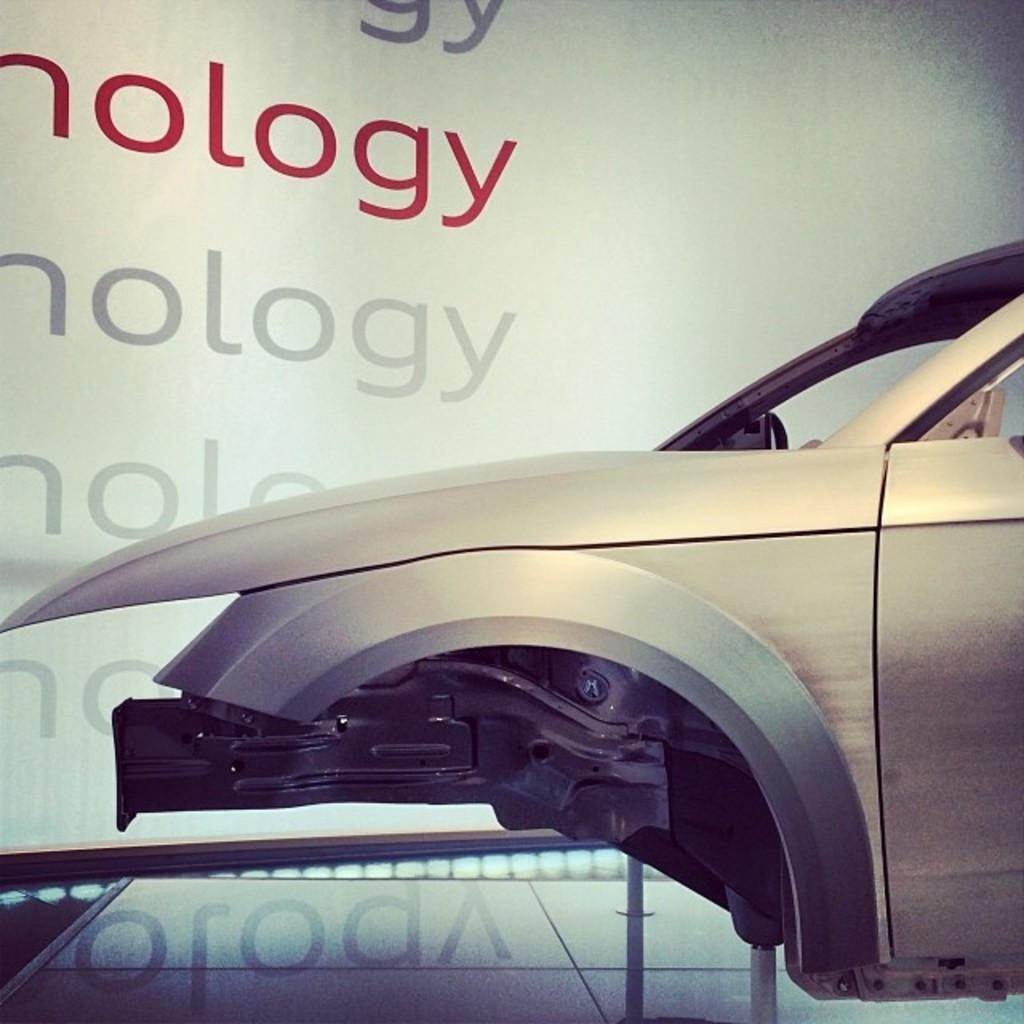What is the main subject of the picture? The main subject of the picture is a vehicle. What can be seen on the back of the vehicle? There is text on a board at the back of the vehicle. What object is located at the bottom of the image? There is a glass at the bottom of the image. What is reflected on the glass in the image? There is a reflection of text on the glass. What type of balloon is being used to decorate the party in the image? There is no party or balloon present in the image. What kind of curve can be seen in the image? There is no curve visible in the image; it features a vehicle, text on a board, a glass, and the reflection of text. 